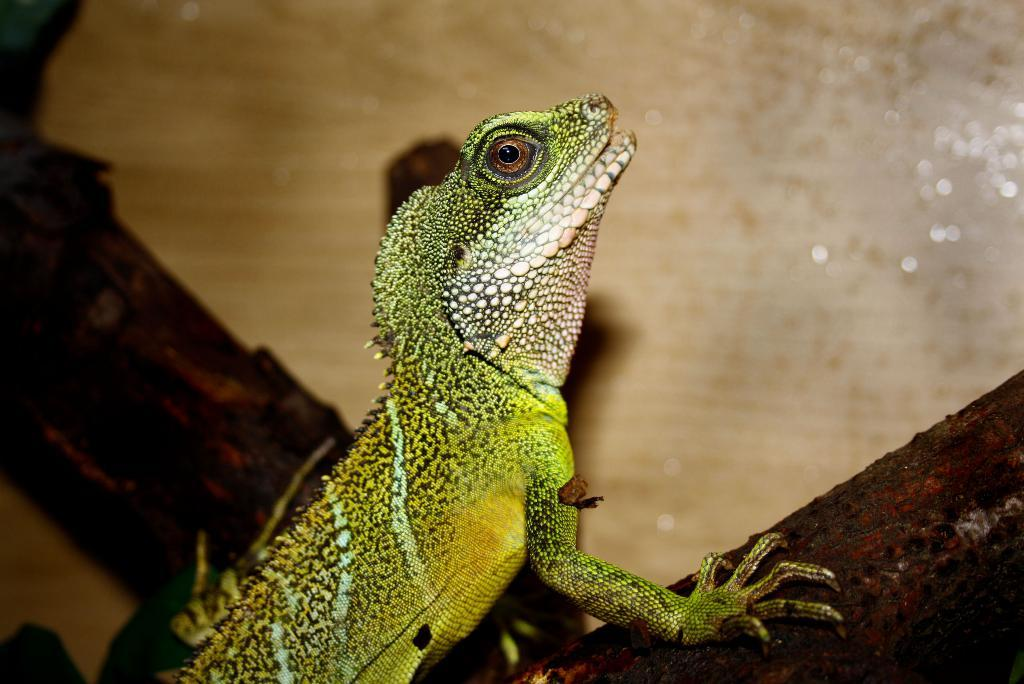What type of animal is in the image? There is a lizard in the image. Where is the lizard located? The lizard is on the stem of a tree. What type of knot is the lizard using to climb the tree in the image? There is no knot present in the image, as the lizard is on the stem of the tree, not climbing it. 